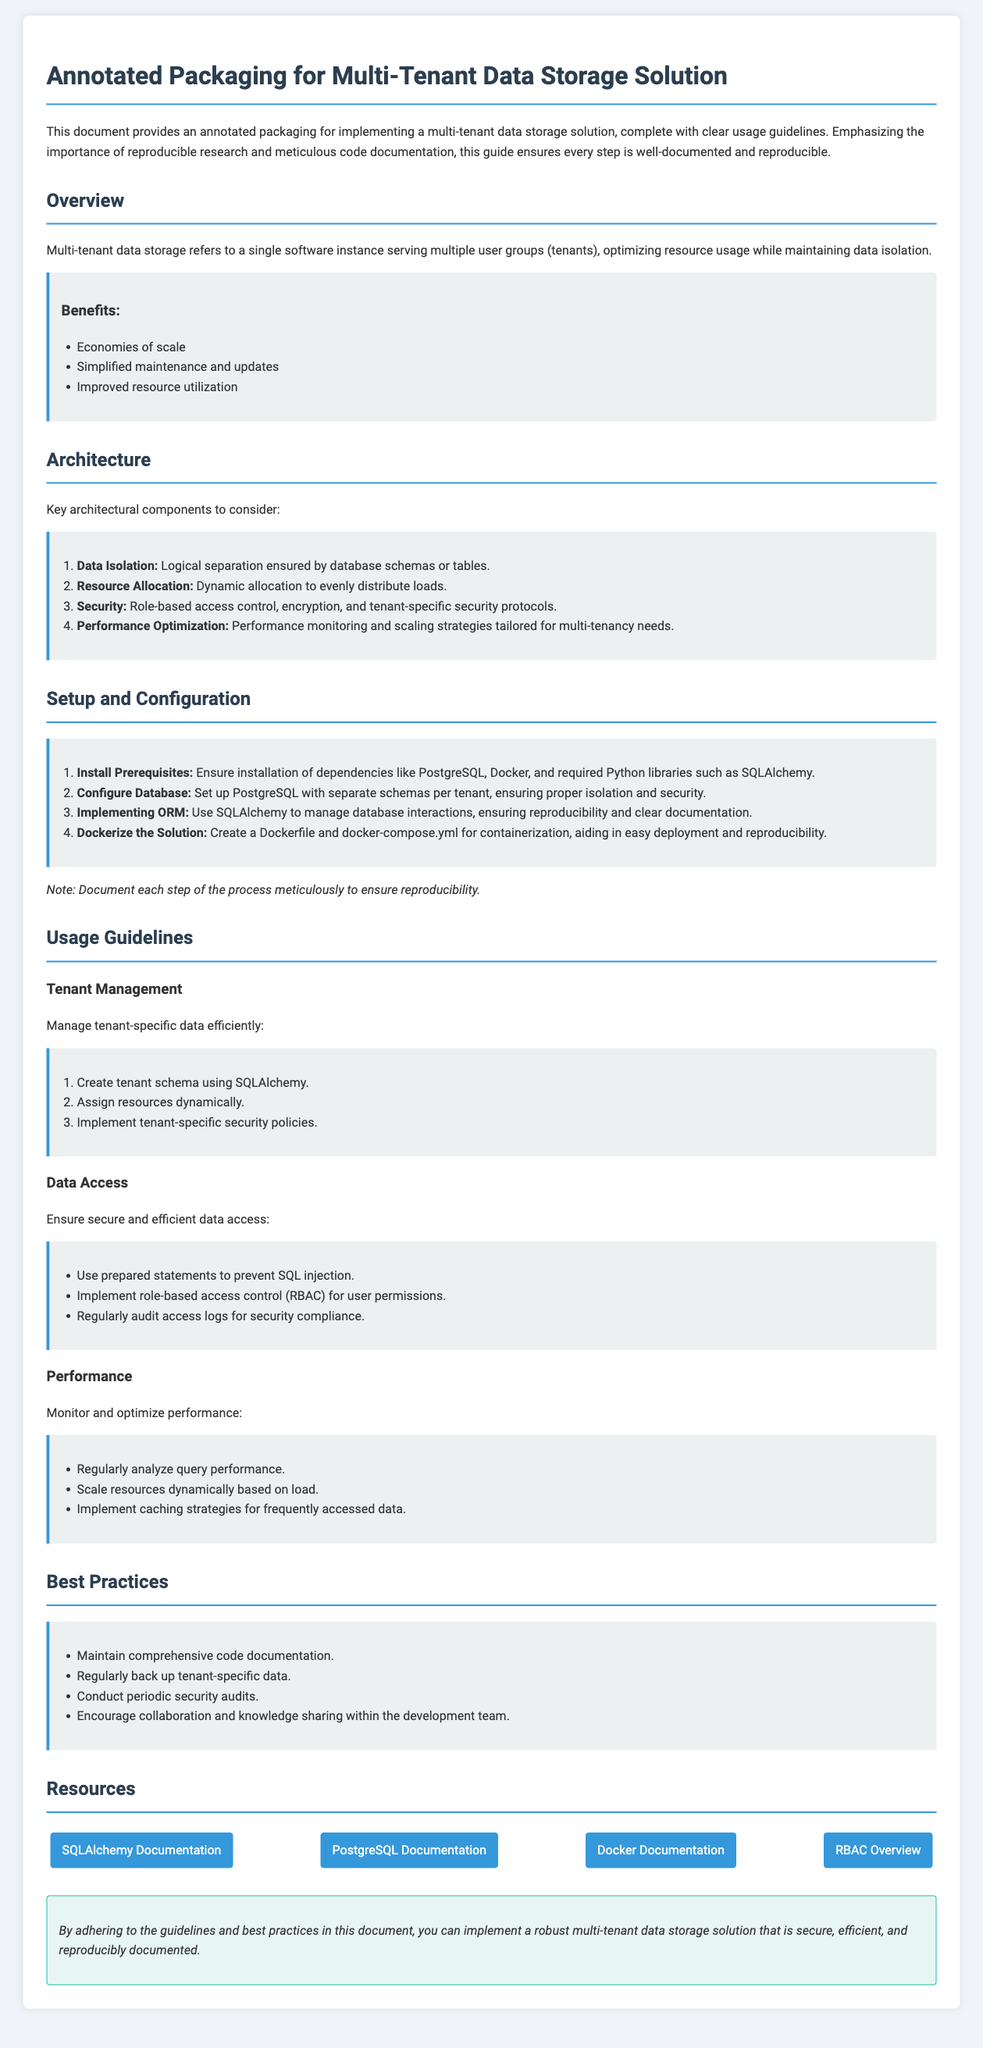What is the purpose of the document? The document provides an annotated packaging for implementing a multi-tenant data storage solution, ensuring every step is well-documented and reproducible.
Answer: Annotated packaging What is one benefit of multi-tenant data storage? The document lists several benefits, one of which is improved resource utilization.
Answer: Improved resource utilization Which database is mentioned as a prerequisite? The installation prerequisites include dependencies like PostgreSQL.
Answer: PostgreSQL What should be implemented for data access? The document advises using prepared statements to prevent SQL injection for secure data access.
Answer: Prepared statements How many key architectural components are there? The document details four key architectural components for multi-tenant data storage.
Answer: Four What is one of the setup steps mentioned? One of the steps for setup is ensuring the installation of dependencies like Docker.
Answer: Docker What type of access control is recommended? The document recommends implementing role-based access control for user permissions.
Answer: Role-based access control What is a best practice in terms of code? The document specifies maintaining comprehensive code documentation as a best practice.
Answer: Comprehensive code documentation What is noted as crucial for reproducibility in the setup? The document emphasizes the importance of documenting each step of the process meticulously for reproducibility.
Answer: Documenting each step 